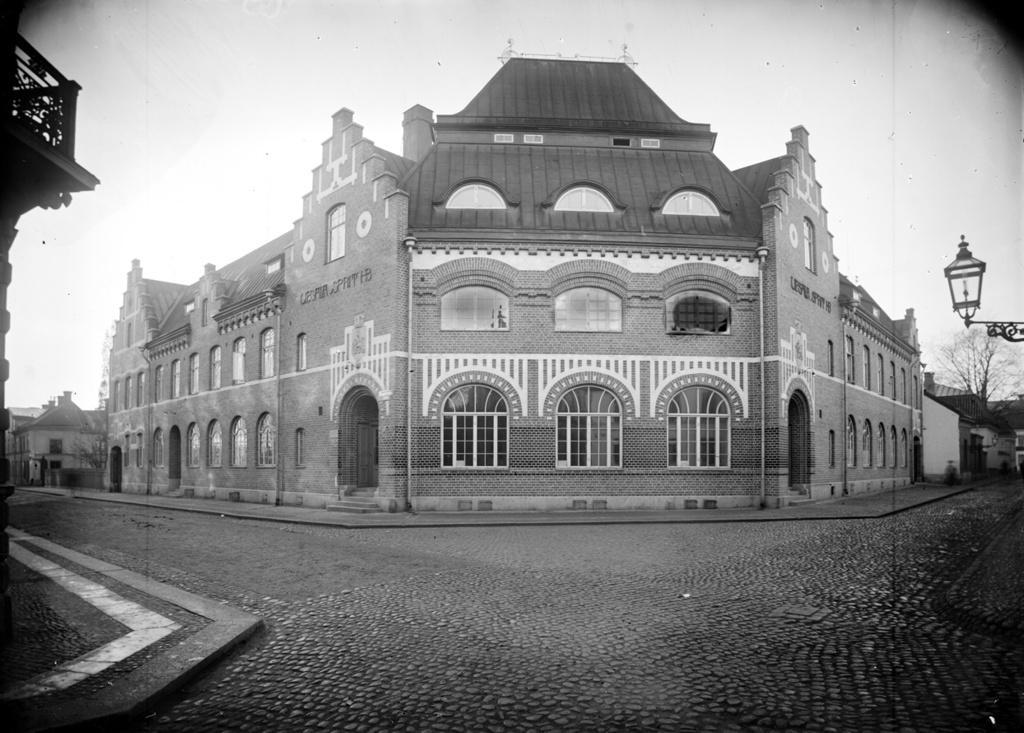How would you summarize this image in a sentence or two? It is a black and white image and in this image we can see the buildings, houses and also trees. On the right we can see the light. At the top there is sky and at the bottom we can see the road. 